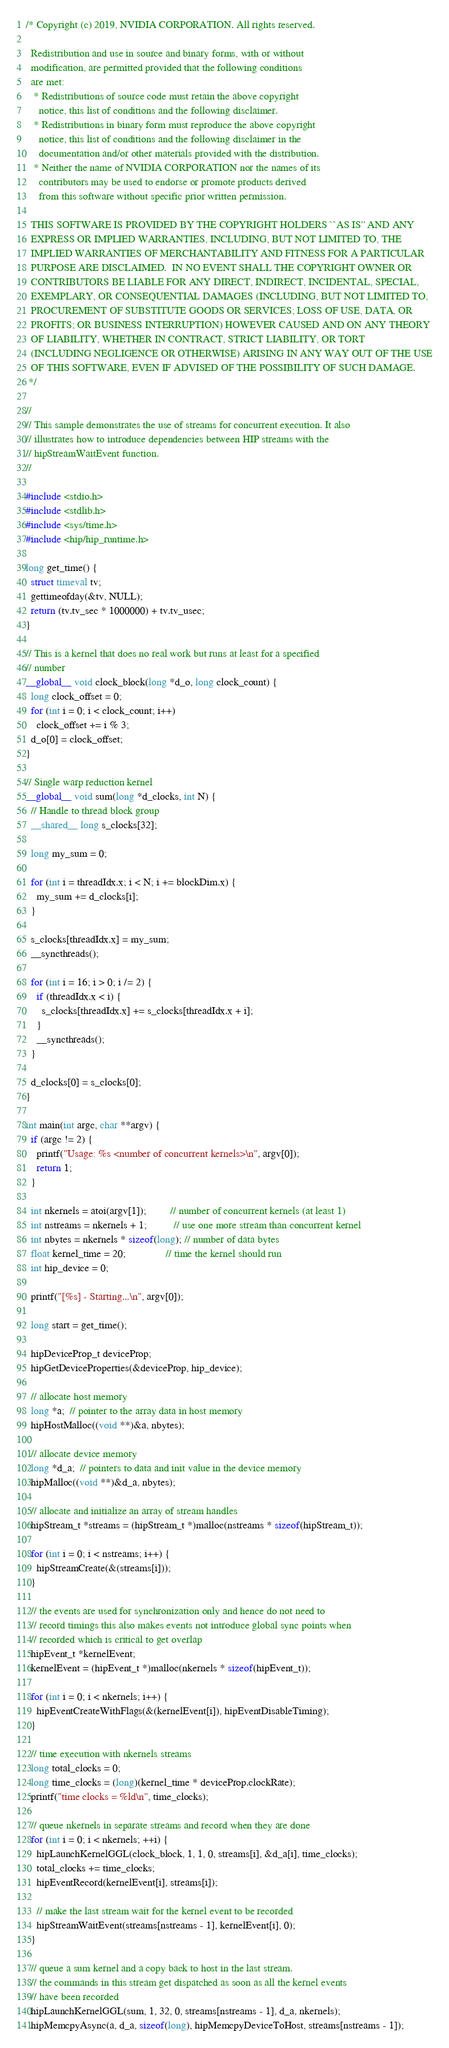<code> <loc_0><loc_0><loc_500><loc_500><_Cuda_>/* Copyright (c) 2019, NVIDIA CORPORATION. All rights reserved.
 
  Redistribution and use in source and binary forms, with or without
  modification, are permitted provided that the following conditions
  are met:
   * Redistributions of source code must retain the above copyright
     notice, this list of conditions and the following disclaimer.
   * Redistributions in binary form must reproduce the above copyright
     notice, this list of conditions and the following disclaimer in the
     documentation and/or other materials provided with the distribution.
   * Neither the name of NVIDIA CORPORATION nor the names of its
     contributors may be used to endorse or promote products derived
     from this software without specific prior written permission.
 
  THIS SOFTWARE IS PROVIDED BY THE COPYRIGHT HOLDERS ``AS IS'' AND ANY
  EXPRESS OR IMPLIED WARRANTIES, INCLUDING, BUT NOT LIMITED TO, THE
  IMPLIED WARRANTIES OF MERCHANTABILITY AND FITNESS FOR A PARTICULAR
  PURPOSE ARE DISCLAIMED.  IN NO EVENT SHALL THE COPYRIGHT OWNER OR
  CONTRIBUTORS BE LIABLE FOR ANY DIRECT, INDIRECT, INCIDENTAL, SPECIAL,
  EXEMPLARY, OR CONSEQUENTIAL DAMAGES (INCLUDING, BUT NOT LIMITED TO,
  PROCUREMENT OF SUBSTITUTE GOODS OR SERVICES; LOSS OF USE, DATA, OR
  PROFITS; OR BUSINESS INTERRUPTION) HOWEVER CAUSED AND ON ANY THEORY
  OF LIABILITY, WHETHER IN CONTRACT, STRICT LIABILITY, OR TORT
  (INCLUDING NEGLIGENCE OR OTHERWISE) ARISING IN ANY WAY OUT OF THE USE
  OF THIS SOFTWARE, EVEN IF ADVISED OF THE POSSIBILITY OF SUCH DAMAGE.
 */

//
// This sample demonstrates the use of streams for concurrent execution. It also
// illustrates how to introduce dependencies between HIP streams with the
// hipStreamWaitEvent function.
//

#include <stdio.h>
#include <stdlib.h>
#include <sys/time.h>
#include <hip/hip_runtime.h>

long get_time() {
  struct timeval tv;
  gettimeofday(&tv, NULL);
  return (tv.tv_sec * 1000000) + tv.tv_usec;
}

// This is a kernel that does no real work but runs at least for a specified
// number
__global__ void clock_block(long *d_o, long clock_count) {
  long clock_offset = 0;
  for (int i = 0; i < clock_count; i++)
    clock_offset += i % 3;
  d_o[0] = clock_offset;
}

// Single warp reduction kernel
__global__ void sum(long *d_clocks, int N) {
  // Handle to thread block group
  __shared__ long s_clocks[32];

  long my_sum = 0;

  for (int i = threadIdx.x; i < N; i += blockDim.x) {
    my_sum += d_clocks[i];
  }

  s_clocks[threadIdx.x] = my_sum;
  __syncthreads();

  for (int i = 16; i > 0; i /= 2) {
    if (threadIdx.x < i) {
      s_clocks[threadIdx.x] += s_clocks[threadIdx.x + i];
    }
    __syncthreads();
  }

  d_clocks[0] = s_clocks[0];
}

int main(int argc, char **argv) {
  if (argc != 2) {
    printf("Usage: %s <number of concurrent kernels>\n", argv[0]);
    return 1;
  }
    
  int nkernels = atoi(argv[1]);         // number of concurrent kernels (at least 1)
  int nstreams = nkernels + 1;          // use one more stream than concurrent kernel
  int nbytes = nkernels * sizeof(long); // number of data bytes
  float kernel_time = 20;               // time the kernel should run
  int hip_device = 0;

  printf("[%s] - Starting...\n", argv[0]);

  long start = get_time();

  hipDeviceProp_t deviceProp;
  hipGetDeviceProperties(&deviceProp, hip_device);

  // allocate host memory
  long *a;  // pointer to the array data in host memory
  hipHostMalloc((void **)&a, nbytes);

  // allocate device memory
  long *d_a;  // pointers to data and init value in the device memory
  hipMalloc((void **)&d_a, nbytes);

  // allocate and initialize an array of stream handles
  hipStream_t *streams = (hipStream_t *)malloc(nstreams * sizeof(hipStream_t));

  for (int i = 0; i < nstreams; i++) {
    hipStreamCreate(&(streams[i]));
  }

  // the events are used for synchronization only and hence do not need to
  // record timings this also makes events not introduce global sync points when
  // recorded which is critical to get overlap
  hipEvent_t *kernelEvent;
  kernelEvent = (hipEvent_t *)malloc(nkernels * sizeof(hipEvent_t));

  for (int i = 0; i < nkernels; i++) {
    hipEventCreateWithFlags(&(kernelEvent[i]), hipEventDisableTiming);
  }

  // time execution with nkernels streams
  long total_clocks = 0;
  long time_clocks = (long)(kernel_time * deviceProp.clockRate);
  printf("time clocks = %ld\n", time_clocks);

  // queue nkernels in separate streams and record when they are done
  for (int i = 0; i < nkernels; ++i) {
    hipLaunchKernelGGL(clock_block, 1, 1, 0, streams[i], &d_a[i], time_clocks);
    total_clocks += time_clocks;
    hipEventRecord(kernelEvent[i], streams[i]);

    // make the last stream wait for the kernel event to be recorded
    hipStreamWaitEvent(streams[nstreams - 1], kernelEvent[i], 0);
  }

  // queue a sum kernel and a copy back to host in the last stream.
  // the commands in this stream get dispatched as soon as all the kernel events
  // have been recorded
  hipLaunchKernelGGL(sum, 1, 32, 0, streams[nstreams - 1], d_a, nkernels);
  hipMemcpyAsync(a, d_a, sizeof(long), hipMemcpyDeviceToHost, streams[nstreams - 1]);
</code> 